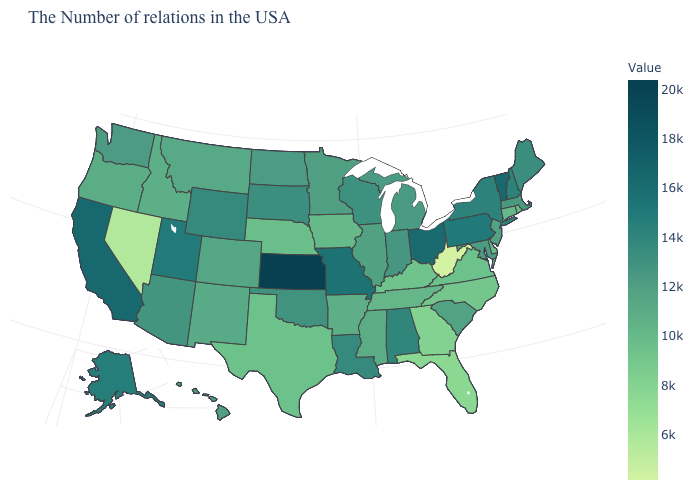Does Delaware have a lower value than North Dakota?
Short answer required. Yes. Which states hav the highest value in the Northeast?
Write a very short answer. Vermont. Does North Dakota have the highest value in the USA?
Quick response, please. No. Does Missouri have a lower value than Kansas?
Quick response, please. Yes. 